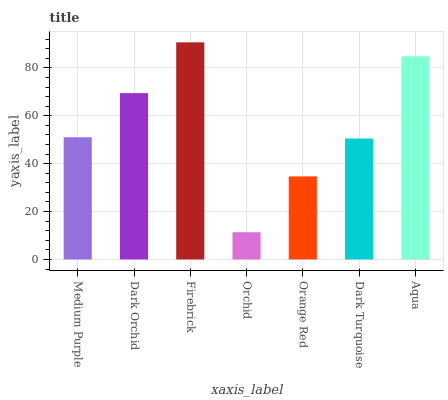Is Orchid the minimum?
Answer yes or no. Yes. Is Firebrick the maximum?
Answer yes or no. Yes. Is Dark Orchid the minimum?
Answer yes or no. No. Is Dark Orchid the maximum?
Answer yes or no. No. Is Dark Orchid greater than Medium Purple?
Answer yes or no. Yes. Is Medium Purple less than Dark Orchid?
Answer yes or no. Yes. Is Medium Purple greater than Dark Orchid?
Answer yes or no. No. Is Dark Orchid less than Medium Purple?
Answer yes or no. No. Is Medium Purple the high median?
Answer yes or no. Yes. Is Medium Purple the low median?
Answer yes or no. Yes. Is Dark Turquoise the high median?
Answer yes or no. No. Is Dark Turquoise the low median?
Answer yes or no. No. 